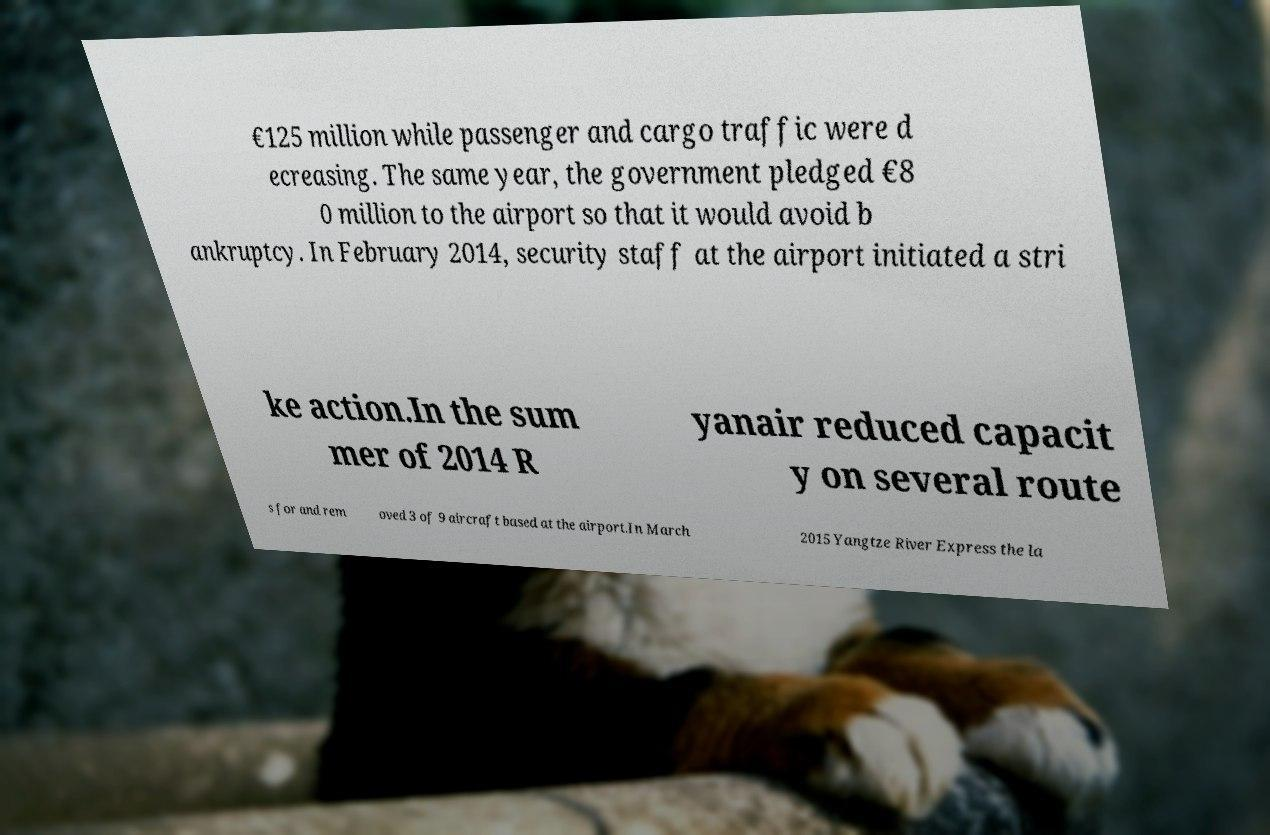There's text embedded in this image that I need extracted. Can you transcribe it verbatim? €125 million while passenger and cargo traffic were d ecreasing. The same year, the government pledged €8 0 million to the airport so that it would avoid b ankruptcy. In February 2014, security staff at the airport initiated a stri ke action.In the sum mer of 2014 R yanair reduced capacit y on several route s for and rem oved 3 of 9 aircraft based at the airport.In March 2015 Yangtze River Express the la 